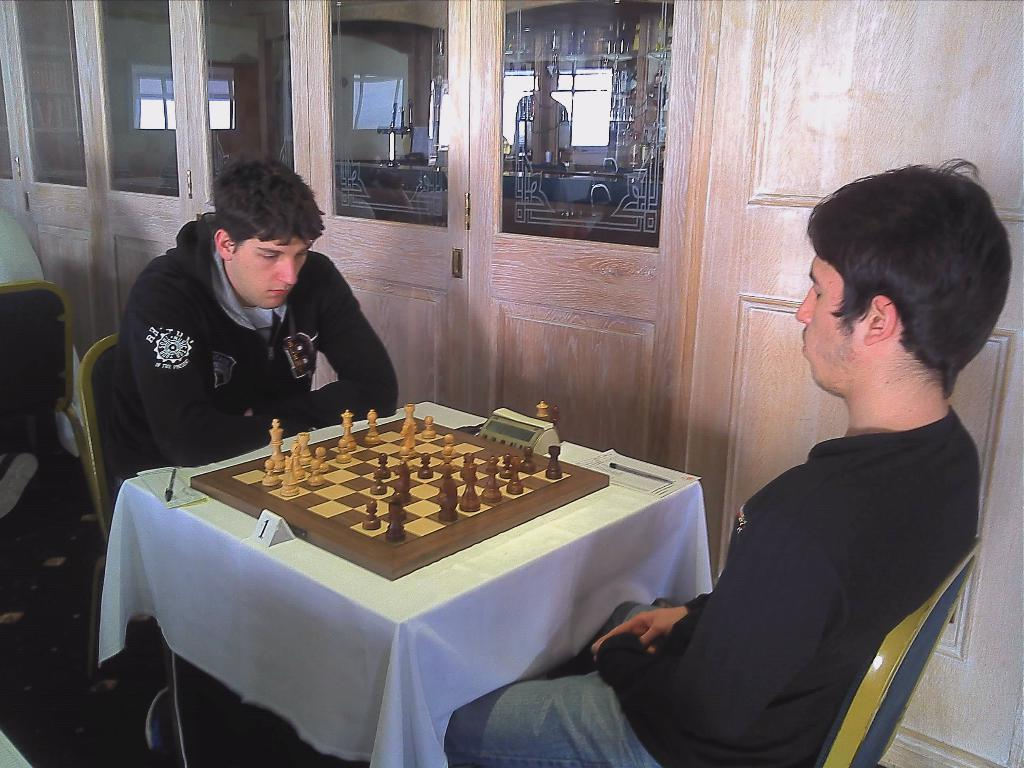How many men are present in the image? There are two men in the image. What are the men doing in the image? The men are sitting on chairs and playing chess. What color coats are the men wearing? Both men are wearing black color coats. Can you see any waves in the image? There are no waves present in the image. What type of action is the neck performing in the image? There is no neck present in the image, as the subjects are two men. 